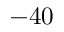<formula> <loc_0><loc_0><loc_500><loc_500>- 4 0</formula> 